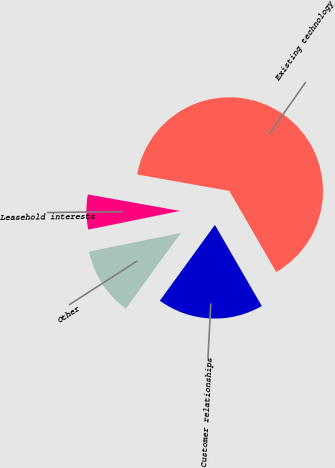Convert chart to OTSL. <chart><loc_0><loc_0><loc_500><loc_500><pie_chart><fcel>Existing technology<fcel>Customer relationships<fcel>Other<fcel>Leasehold interests<nl><fcel>63.84%<fcel>18.34%<fcel>11.8%<fcel>6.02%<nl></chart> 